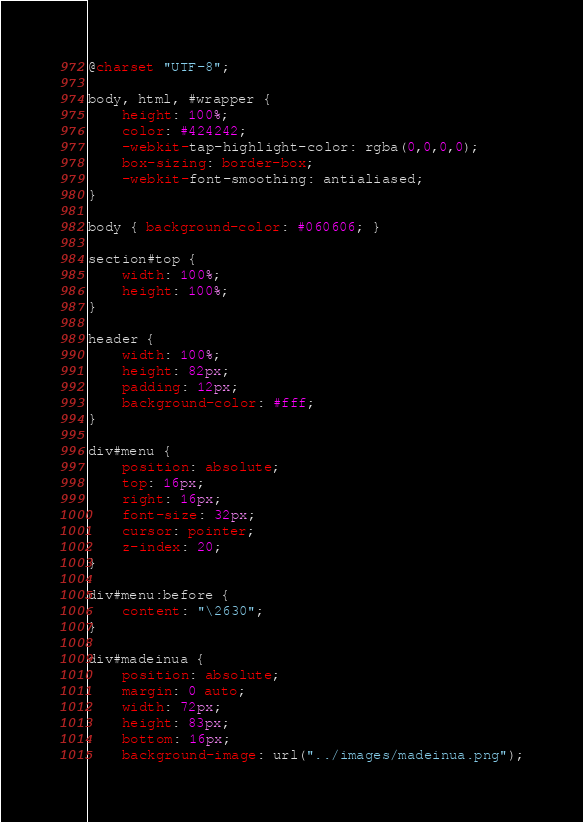Convert code to text. <code><loc_0><loc_0><loc_500><loc_500><_CSS_>@charset "UTF-8";

body, html, #wrapper {
	height: 100%;
	color: #424242;
	-webkit-tap-highlight-color: rgba(0,0,0,0);
	box-sizing: border-box;
	-webkit-font-smoothing: antialiased;
}

body { background-color: #060606; }

section#top {
	width: 100%;
	height: 100%;
}

header {
	width: 100%;
	height: 82px;
	padding: 12px;
	background-color: #fff;
}

div#menu {
	position: absolute;
	top: 16px;
	right: 16px;
	font-size: 32px;
	cursor: pointer;
	z-index: 20;
}

div#menu:before {
	content: "\2630";
}

div#madeinua {
	position: absolute;
	margin: 0 auto;
	width: 72px;
	height: 83px;
	bottom: 16px;
	background-image: url("../images/madeinua.png");</code> 